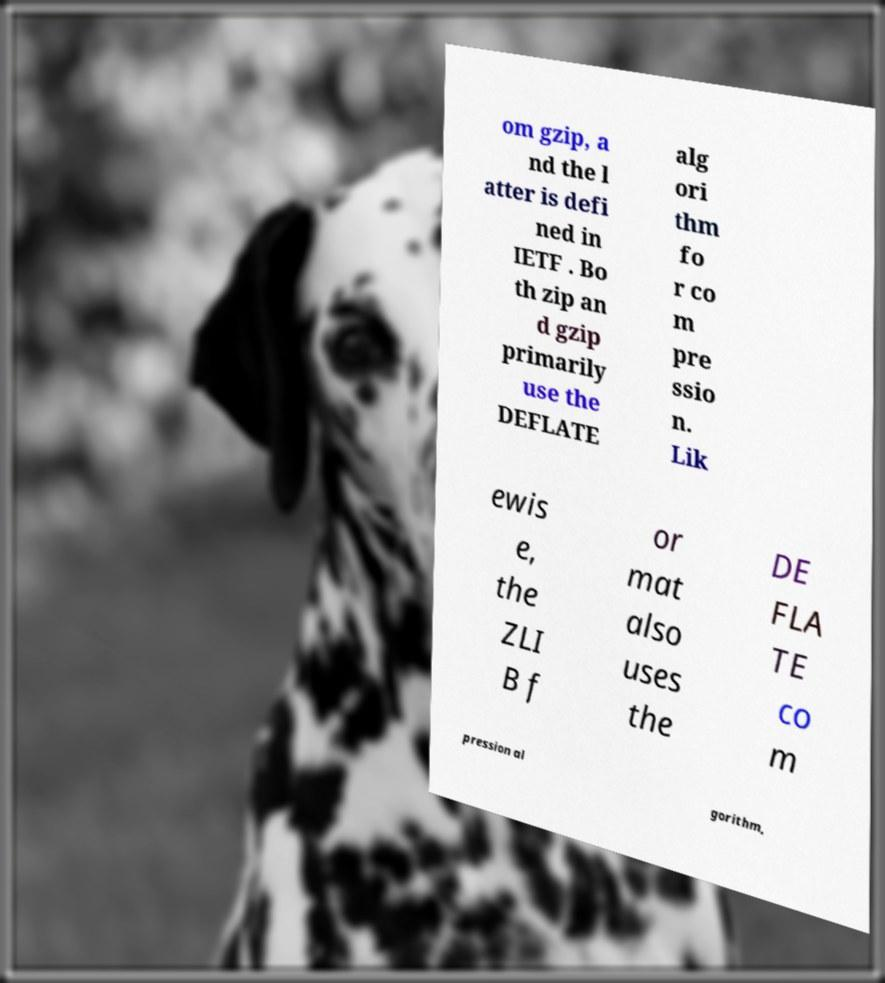Please read and relay the text visible in this image. What does it say? om gzip, a nd the l atter is defi ned in IETF . Bo th zip an d gzip primarily use the DEFLATE alg ori thm fo r co m pre ssio n. Lik ewis e, the ZLI B f or mat also uses the DE FLA TE co m pression al gorithm, 